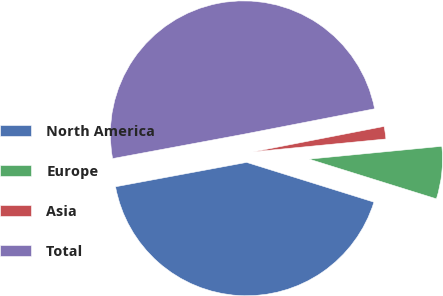Convert chart to OTSL. <chart><loc_0><loc_0><loc_500><loc_500><pie_chart><fcel>North America<fcel>Europe<fcel>Asia<fcel>Total<nl><fcel>42.26%<fcel>6.35%<fcel>1.52%<fcel>49.87%<nl></chart> 